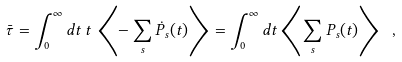<formula> <loc_0><loc_0><loc_500><loc_500>\bar { \tau } = \int _ { 0 } ^ { \infty } d t \, t \, \left \langle - \sum _ { s } \dot { P } _ { s } ( t ) \right \rangle = \int _ { 0 } ^ { \infty } d t \left \langle \sum _ { s } P _ { s } ( t ) \right \rangle \ ,</formula> 